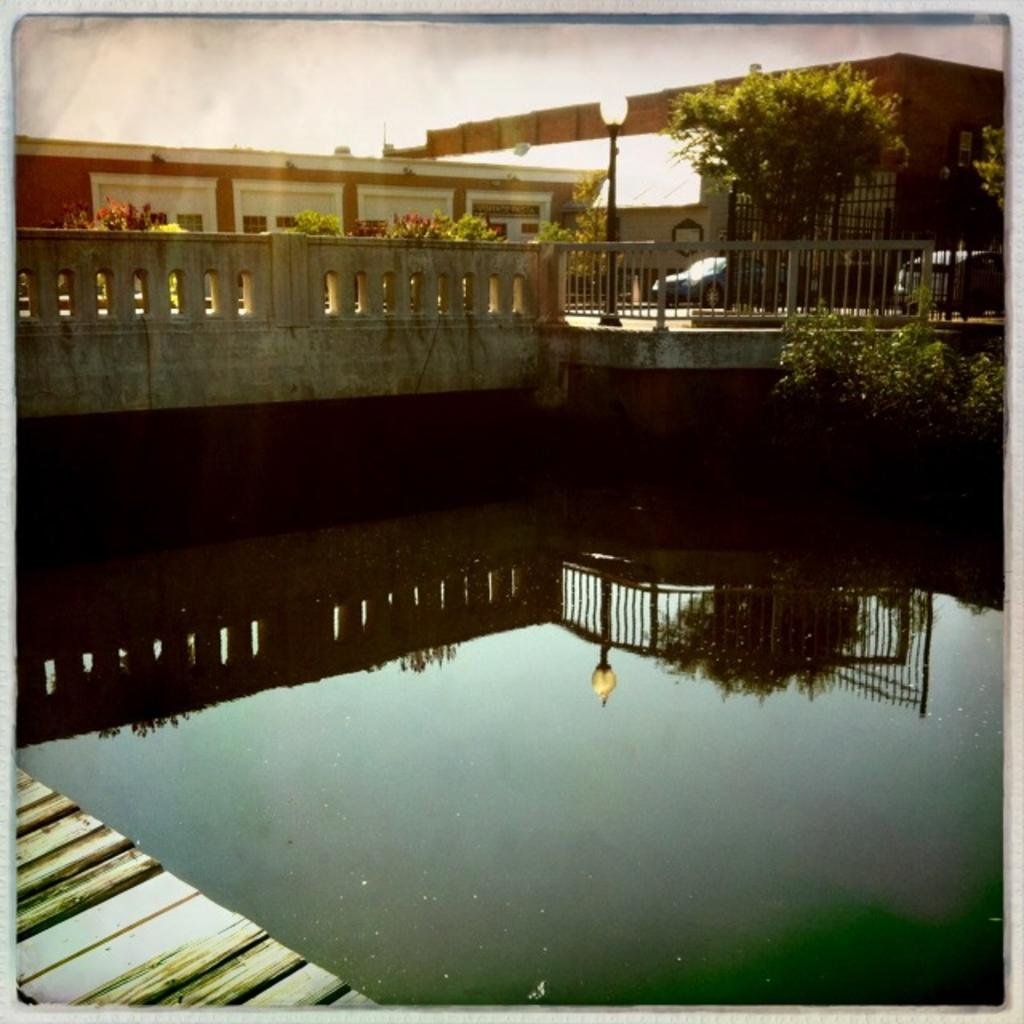What type of structure is present in the image? There is a house in the image. What else can be seen in the image besides the house? There are many plants and 2 vehicles in the image. Is there a way to navigate through the area in the image? Yes, there is a path in the image. What natural element is visible in the image? There is water visible in the image. What direction is the ant moving in the image? There is no ant present in the image. What type of cast is visible on the house in the image? There is no cast visible on the house in the image. 